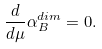<formula> <loc_0><loc_0><loc_500><loc_500>\frac { d } { d \mu } \alpha _ { B } ^ { d i m } = 0 .</formula> 